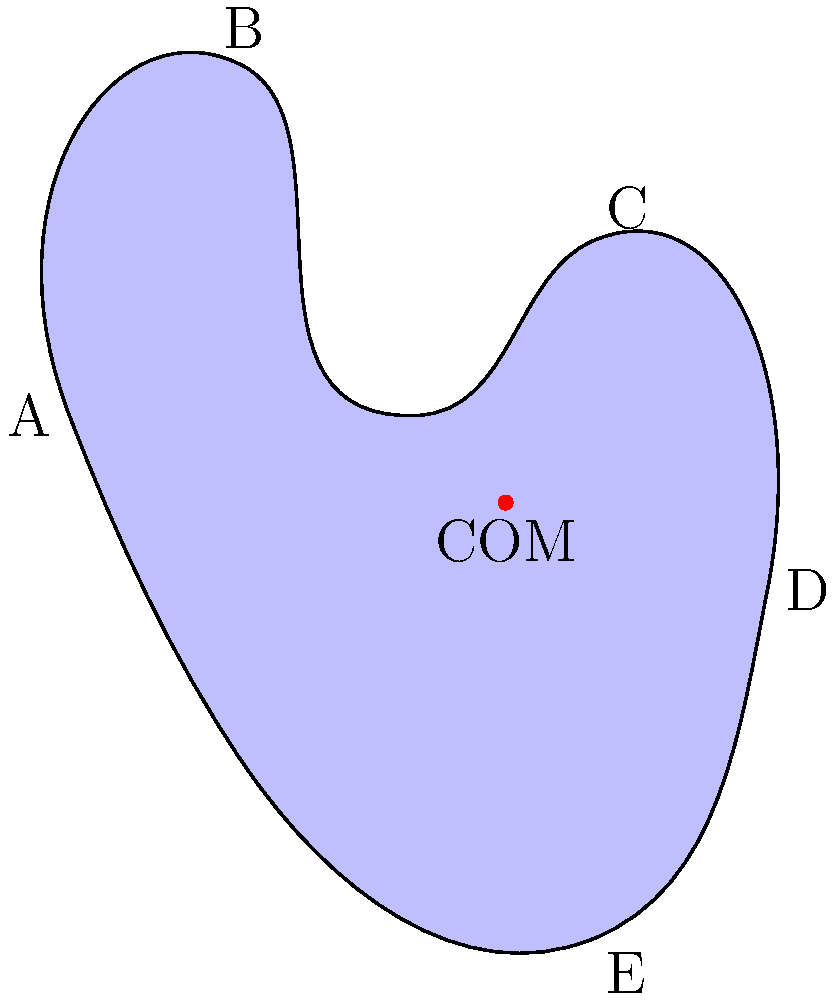As a book editor reviewing a collection of cartoons, you come across an irregularly shaped character. The illustrator claims they've accurately represented the character's center of mass (COM). Given that the character's shape can be approximated by the points A(-1,2), B(0,4), C(2,3), D(3,1), and E(2,-1), with the COM marked at (1.5,1.5), how would you verify the accuracy of the illustrator's claim? What physical principle would you use to explain your reasoning? To verify the accuracy of the illustrator's claim about the center of mass (COM), we can use the principle of moments. Here's a step-by-step explanation:

1. The center of mass is the point where the entire mass of an object can be considered to be concentrated for certain calculations.

2. For a system of discrete points, the COM coordinates $(x_{COM}, y_{COM})$ are given by:

   $$x_{COM} = \frac{\sum_{i} m_i x_i}{\sum_{i} m_i}$$
   $$y_{COM} = \frac{\sum_{i} m_i y_i}{\sum_{i} m_i}$$

   where $m_i$ is the mass at point $(x_i, y_i)$.

3. Assuming equal mass at each point for simplicity, we can calculate:

   $$x_{COM} = \frac{(-1 + 0 + 2 + 3 + 2)}{5} = \frac{6}{5} = 1.2$$
   $$y_{COM} = \frac{(2 + 4 + 3 + 1 - 1)}{5} = \frac{9}{5} = 1.8$$

4. The calculated COM (1.2, 1.8) is close to, but not exactly at, the marked point (1.5, 1.5).

5. The discrepancy could be due to:
   a) The assumption of equal masses at each point
   b) The continuous nature of the actual shape vs. our discrete point approximation
   c) Possible artistic license in the illustration

6. To more accurately verify the COM, we would need to:
   a) Consider the actual mass distribution of the character
   b) Use integration for a continuous shape rather than discrete points
   c) Possibly use physical methods like balancing the cutout of the character

In conclusion, while the illustrator's representation is reasonably close, it may not be precisely accurate based on our simplified calculation. However, for artistic purposes, this level of accuracy might be sufficient.
Answer: The claim can be approximately verified using the principle of moments, calculating COM coordinates as averages of point coordinates. The result (1.2, 1.8) is close to the marked (1.5, 1.5), suggesting reasonable accuracy for artistic purposes. 